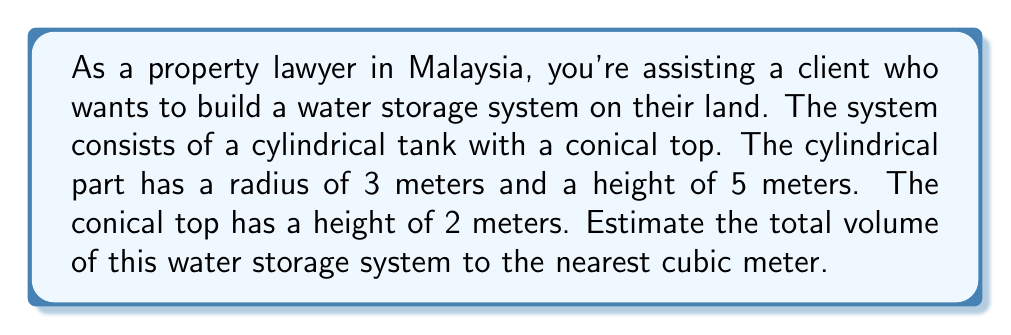Help me with this question. To solve this problem, we need to calculate the volumes of the cylindrical part and the conical part separately, then add them together.

1. Volume of the cylindrical part:
   The formula for the volume of a cylinder is $V_c = \pi r^2 h$
   Where $r$ is the radius and $h$ is the height.
   
   $$V_c = \pi (3 \text{ m})^2 (5 \text{ m}) = 45\pi \text{ m}^3$$

2. Volume of the conical part:
   The formula for the volume of a cone is $V_n = \frac{1}{3}\pi r^2 h$
   Where $r$ is the radius of the base and $h$ is the height.
   
   $$V_n = \frac{1}{3}\pi (3 \text{ m})^2 (2 \text{ m}) = 6\pi \text{ m}^3$$

3. Total volume:
   $$V_{\text{total}} = V_c + V_n = 45\pi \text{ m}^3 + 6\pi \text{ m}^3 = 51\pi \text{ m}^3$$

4. Calculate the numerical value:
   $$51\pi \approx 160.22 \text{ m}^3$$

5. Round to the nearest cubic meter:
   160.22 m³ rounds to 160 m³

[asy]
import three;
size(200);
currentprojection=perspective(6,3,2);

// Draw cylinder
draw(surface(circle((0,0,0),3))--surface(circle((0,0,5),3)),lightgray);
draw(circle((0,0,0),3));
draw(circle((0,0,5),3));

// Draw cone
draw(surface(circle((0,0,5),3)---(0,0,7)),lightgray);

// Labels
label("3 m", (3.5,0,2.5));
label("5 m", (-3.5,0,2.5));
label("2 m", (0,3.5,6));
[/asy]
Answer: The estimated volume of the water storage system is 160 cubic meters. 